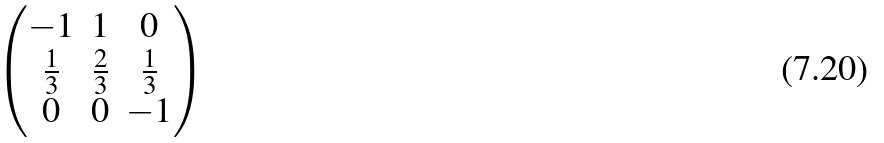Convert formula to latex. <formula><loc_0><loc_0><loc_500><loc_500>\begin{pmatrix} - 1 & 1 & 0 \\ \frac { 1 } { 3 } & \frac { 2 } { 3 } & \frac { 1 } { 3 } \\ 0 & 0 & - 1 \end{pmatrix}</formula> 